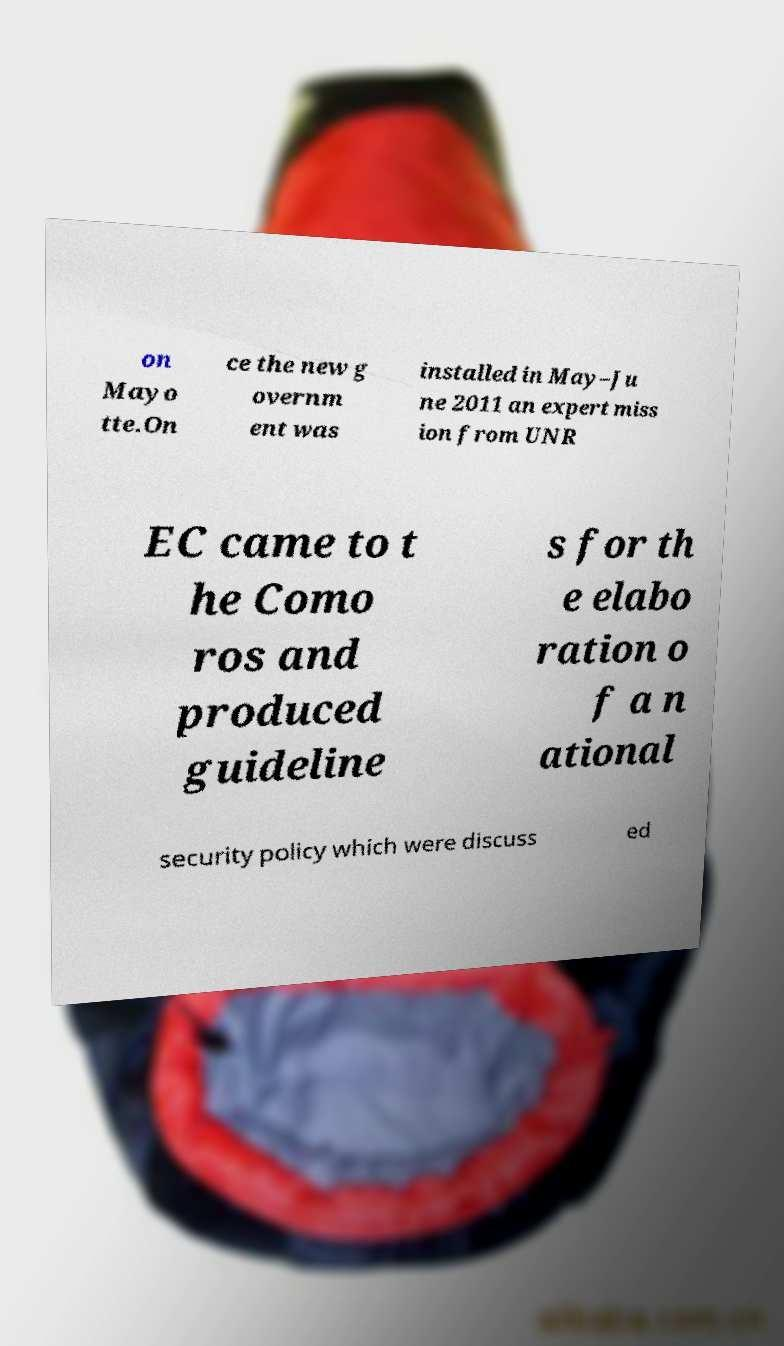Please identify and transcribe the text found in this image. on Mayo tte.On ce the new g overnm ent was installed in May–Ju ne 2011 an expert miss ion from UNR EC came to t he Como ros and produced guideline s for th e elabo ration o f a n ational security policy which were discuss ed 